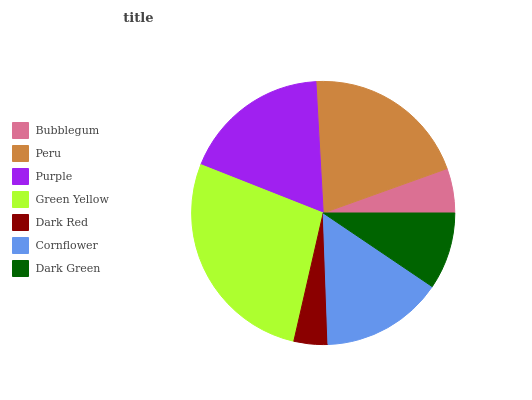Is Dark Red the minimum?
Answer yes or no. Yes. Is Green Yellow the maximum?
Answer yes or no. Yes. Is Peru the minimum?
Answer yes or no. No. Is Peru the maximum?
Answer yes or no. No. Is Peru greater than Bubblegum?
Answer yes or no. Yes. Is Bubblegum less than Peru?
Answer yes or no. Yes. Is Bubblegum greater than Peru?
Answer yes or no. No. Is Peru less than Bubblegum?
Answer yes or no. No. Is Cornflower the high median?
Answer yes or no. Yes. Is Cornflower the low median?
Answer yes or no. Yes. Is Green Yellow the high median?
Answer yes or no. No. Is Peru the low median?
Answer yes or no. No. 